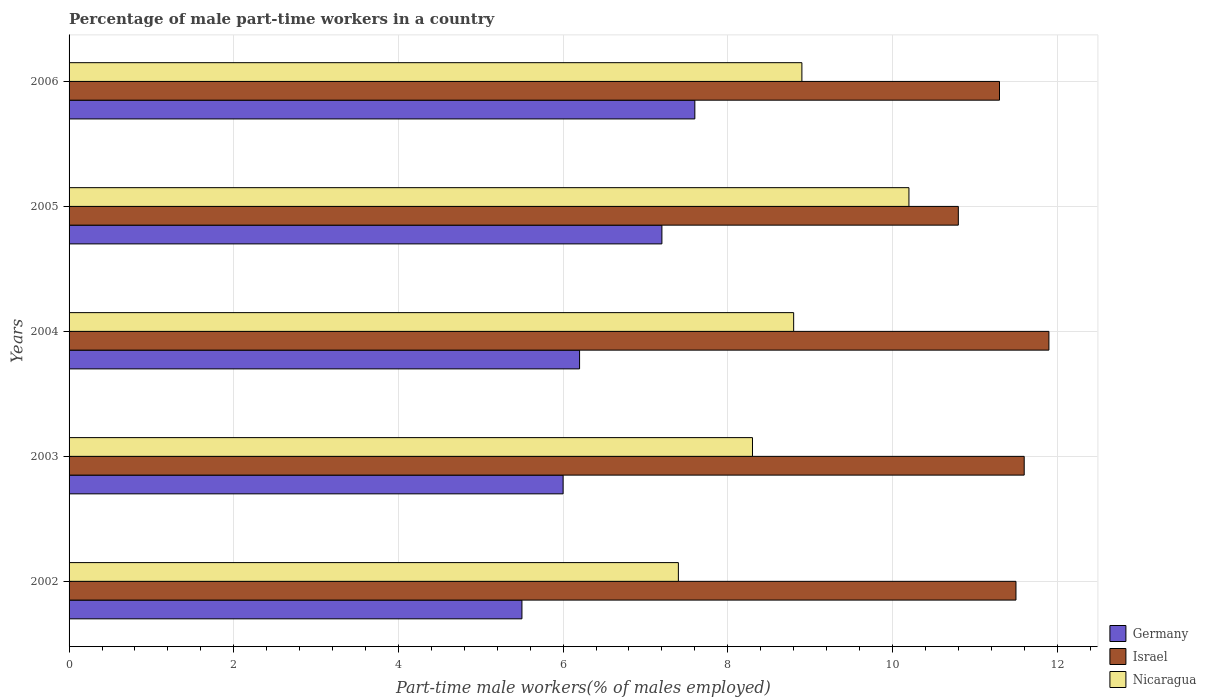Are the number of bars on each tick of the Y-axis equal?
Offer a terse response. Yes. How many bars are there on the 5th tick from the top?
Your answer should be very brief. 3. How many bars are there on the 1st tick from the bottom?
Offer a very short reply. 3. What is the label of the 3rd group of bars from the top?
Your answer should be very brief. 2004. In how many cases, is the number of bars for a given year not equal to the number of legend labels?
Ensure brevity in your answer.  0. What is the percentage of male part-time workers in Israel in 2006?
Give a very brief answer. 11.3. Across all years, what is the maximum percentage of male part-time workers in Nicaragua?
Ensure brevity in your answer.  10.2. Across all years, what is the minimum percentage of male part-time workers in Israel?
Your answer should be very brief. 10.8. What is the total percentage of male part-time workers in Nicaragua in the graph?
Your answer should be very brief. 43.6. What is the difference between the percentage of male part-time workers in Germany in 2002 and that in 2003?
Offer a terse response. -0.5. What is the difference between the percentage of male part-time workers in Israel in 2004 and the percentage of male part-time workers in Nicaragua in 2003?
Provide a short and direct response. 3.6. What is the average percentage of male part-time workers in Nicaragua per year?
Your answer should be compact. 8.72. In the year 2003, what is the difference between the percentage of male part-time workers in Israel and percentage of male part-time workers in Nicaragua?
Give a very brief answer. 3.3. What is the ratio of the percentage of male part-time workers in Israel in 2003 to that in 2004?
Keep it short and to the point. 0.97. Is the difference between the percentage of male part-time workers in Israel in 2004 and 2006 greater than the difference between the percentage of male part-time workers in Nicaragua in 2004 and 2006?
Give a very brief answer. Yes. What is the difference between the highest and the second highest percentage of male part-time workers in Nicaragua?
Provide a succinct answer. 1.3. What is the difference between the highest and the lowest percentage of male part-time workers in Nicaragua?
Provide a short and direct response. 2.8. In how many years, is the percentage of male part-time workers in Nicaragua greater than the average percentage of male part-time workers in Nicaragua taken over all years?
Ensure brevity in your answer.  3. What does the 1st bar from the top in 2002 represents?
Make the answer very short. Nicaragua. What is the difference between two consecutive major ticks on the X-axis?
Your answer should be compact. 2. Are the values on the major ticks of X-axis written in scientific E-notation?
Give a very brief answer. No. Does the graph contain any zero values?
Offer a terse response. No. How are the legend labels stacked?
Your answer should be very brief. Vertical. What is the title of the graph?
Keep it short and to the point. Percentage of male part-time workers in a country. Does "Lithuania" appear as one of the legend labels in the graph?
Your answer should be compact. No. What is the label or title of the X-axis?
Ensure brevity in your answer.  Part-time male workers(% of males employed). What is the label or title of the Y-axis?
Ensure brevity in your answer.  Years. What is the Part-time male workers(% of males employed) in Germany in 2002?
Your response must be concise. 5.5. What is the Part-time male workers(% of males employed) of Nicaragua in 2002?
Your response must be concise. 7.4. What is the Part-time male workers(% of males employed) of Germany in 2003?
Your answer should be compact. 6. What is the Part-time male workers(% of males employed) in Israel in 2003?
Give a very brief answer. 11.6. What is the Part-time male workers(% of males employed) in Nicaragua in 2003?
Offer a very short reply. 8.3. What is the Part-time male workers(% of males employed) of Germany in 2004?
Offer a terse response. 6.2. What is the Part-time male workers(% of males employed) in Israel in 2004?
Offer a terse response. 11.9. What is the Part-time male workers(% of males employed) in Nicaragua in 2004?
Make the answer very short. 8.8. What is the Part-time male workers(% of males employed) of Germany in 2005?
Provide a succinct answer. 7.2. What is the Part-time male workers(% of males employed) in Israel in 2005?
Your answer should be very brief. 10.8. What is the Part-time male workers(% of males employed) of Nicaragua in 2005?
Your answer should be compact. 10.2. What is the Part-time male workers(% of males employed) of Germany in 2006?
Make the answer very short. 7.6. What is the Part-time male workers(% of males employed) of Israel in 2006?
Keep it short and to the point. 11.3. What is the Part-time male workers(% of males employed) in Nicaragua in 2006?
Provide a short and direct response. 8.9. Across all years, what is the maximum Part-time male workers(% of males employed) of Germany?
Your answer should be compact. 7.6. Across all years, what is the maximum Part-time male workers(% of males employed) of Israel?
Give a very brief answer. 11.9. Across all years, what is the maximum Part-time male workers(% of males employed) in Nicaragua?
Your answer should be compact. 10.2. Across all years, what is the minimum Part-time male workers(% of males employed) of Israel?
Your response must be concise. 10.8. Across all years, what is the minimum Part-time male workers(% of males employed) in Nicaragua?
Make the answer very short. 7.4. What is the total Part-time male workers(% of males employed) of Germany in the graph?
Give a very brief answer. 32.5. What is the total Part-time male workers(% of males employed) of Israel in the graph?
Keep it short and to the point. 57.1. What is the total Part-time male workers(% of males employed) in Nicaragua in the graph?
Make the answer very short. 43.6. What is the difference between the Part-time male workers(% of males employed) of Germany in 2002 and that in 2004?
Give a very brief answer. -0.7. What is the difference between the Part-time male workers(% of males employed) of Israel in 2002 and that in 2004?
Provide a succinct answer. -0.4. What is the difference between the Part-time male workers(% of males employed) in Nicaragua in 2002 and that in 2004?
Offer a terse response. -1.4. What is the difference between the Part-time male workers(% of males employed) in Germany in 2002 and that in 2005?
Offer a very short reply. -1.7. What is the difference between the Part-time male workers(% of males employed) of Israel in 2002 and that in 2005?
Make the answer very short. 0.7. What is the difference between the Part-time male workers(% of males employed) of Germany in 2002 and that in 2006?
Make the answer very short. -2.1. What is the difference between the Part-time male workers(% of males employed) in Germany in 2003 and that in 2004?
Your response must be concise. -0.2. What is the difference between the Part-time male workers(% of males employed) of Israel in 2003 and that in 2004?
Offer a very short reply. -0.3. What is the difference between the Part-time male workers(% of males employed) of Germany in 2003 and that in 2005?
Offer a very short reply. -1.2. What is the difference between the Part-time male workers(% of males employed) in Israel in 2003 and that in 2005?
Give a very brief answer. 0.8. What is the difference between the Part-time male workers(% of males employed) of Nicaragua in 2003 and that in 2005?
Ensure brevity in your answer.  -1.9. What is the difference between the Part-time male workers(% of males employed) in Germany in 2003 and that in 2006?
Provide a succinct answer. -1.6. What is the difference between the Part-time male workers(% of males employed) of Nicaragua in 2003 and that in 2006?
Keep it short and to the point. -0.6. What is the difference between the Part-time male workers(% of males employed) of Israel in 2004 and that in 2005?
Provide a short and direct response. 1.1. What is the difference between the Part-time male workers(% of males employed) of Nicaragua in 2004 and that in 2005?
Offer a terse response. -1.4. What is the difference between the Part-time male workers(% of males employed) of Israel in 2004 and that in 2006?
Provide a short and direct response. 0.6. What is the difference between the Part-time male workers(% of males employed) of Israel in 2005 and that in 2006?
Offer a very short reply. -0.5. What is the difference between the Part-time male workers(% of males employed) of Germany in 2002 and the Part-time male workers(% of males employed) of Israel in 2003?
Offer a terse response. -6.1. What is the difference between the Part-time male workers(% of males employed) in Germany in 2002 and the Part-time male workers(% of males employed) in Nicaragua in 2003?
Make the answer very short. -2.8. What is the difference between the Part-time male workers(% of males employed) in Israel in 2002 and the Part-time male workers(% of males employed) in Nicaragua in 2003?
Keep it short and to the point. 3.2. What is the difference between the Part-time male workers(% of males employed) of Germany in 2002 and the Part-time male workers(% of males employed) of Israel in 2004?
Give a very brief answer. -6.4. What is the difference between the Part-time male workers(% of males employed) in Germany in 2002 and the Part-time male workers(% of males employed) in Nicaragua in 2004?
Make the answer very short. -3.3. What is the difference between the Part-time male workers(% of males employed) in Germany in 2002 and the Part-time male workers(% of males employed) in Israel in 2005?
Keep it short and to the point. -5.3. What is the difference between the Part-time male workers(% of males employed) in Israel in 2002 and the Part-time male workers(% of males employed) in Nicaragua in 2005?
Offer a very short reply. 1.3. What is the difference between the Part-time male workers(% of males employed) of Israel in 2003 and the Part-time male workers(% of males employed) of Nicaragua in 2004?
Provide a short and direct response. 2.8. What is the difference between the Part-time male workers(% of males employed) in Germany in 2003 and the Part-time male workers(% of males employed) in Israel in 2005?
Your answer should be compact. -4.8. What is the difference between the Part-time male workers(% of males employed) of Germany in 2003 and the Part-time male workers(% of males employed) of Nicaragua in 2006?
Offer a terse response. -2.9. What is the difference between the Part-time male workers(% of males employed) in Germany in 2004 and the Part-time male workers(% of males employed) in Israel in 2005?
Give a very brief answer. -4.6. What is the difference between the Part-time male workers(% of males employed) of Germany in 2004 and the Part-time male workers(% of males employed) of Nicaragua in 2005?
Make the answer very short. -4. What is the difference between the Part-time male workers(% of males employed) in Israel in 2004 and the Part-time male workers(% of males employed) in Nicaragua in 2005?
Keep it short and to the point. 1.7. What is the difference between the Part-time male workers(% of males employed) in Germany in 2004 and the Part-time male workers(% of males employed) in Israel in 2006?
Ensure brevity in your answer.  -5.1. What is the difference between the Part-time male workers(% of males employed) of Germany in 2005 and the Part-time male workers(% of males employed) of Nicaragua in 2006?
Make the answer very short. -1.7. What is the difference between the Part-time male workers(% of males employed) of Israel in 2005 and the Part-time male workers(% of males employed) of Nicaragua in 2006?
Provide a short and direct response. 1.9. What is the average Part-time male workers(% of males employed) of Israel per year?
Offer a terse response. 11.42. What is the average Part-time male workers(% of males employed) in Nicaragua per year?
Your response must be concise. 8.72. In the year 2002, what is the difference between the Part-time male workers(% of males employed) of Germany and Part-time male workers(% of males employed) of Nicaragua?
Give a very brief answer. -1.9. In the year 2003, what is the difference between the Part-time male workers(% of males employed) in Germany and Part-time male workers(% of males employed) in Israel?
Your answer should be very brief. -5.6. In the year 2004, what is the difference between the Part-time male workers(% of males employed) of Germany and Part-time male workers(% of males employed) of Nicaragua?
Your response must be concise. -2.6. In the year 2004, what is the difference between the Part-time male workers(% of males employed) in Israel and Part-time male workers(% of males employed) in Nicaragua?
Give a very brief answer. 3.1. In the year 2005, what is the difference between the Part-time male workers(% of males employed) of Germany and Part-time male workers(% of males employed) of Israel?
Offer a terse response. -3.6. In the year 2005, what is the difference between the Part-time male workers(% of males employed) in Israel and Part-time male workers(% of males employed) in Nicaragua?
Offer a terse response. 0.6. In the year 2006, what is the difference between the Part-time male workers(% of males employed) in Germany and Part-time male workers(% of males employed) in Israel?
Provide a short and direct response. -3.7. In the year 2006, what is the difference between the Part-time male workers(% of males employed) in Germany and Part-time male workers(% of males employed) in Nicaragua?
Make the answer very short. -1.3. What is the ratio of the Part-time male workers(% of males employed) of Germany in 2002 to that in 2003?
Your response must be concise. 0.92. What is the ratio of the Part-time male workers(% of males employed) in Nicaragua in 2002 to that in 2003?
Provide a short and direct response. 0.89. What is the ratio of the Part-time male workers(% of males employed) in Germany in 2002 to that in 2004?
Keep it short and to the point. 0.89. What is the ratio of the Part-time male workers(% of males employed) of Israel in 2002 to that in 2004?
Offer a very short reply. 0.97. What is the ratio of the Part-time male workers(% of males employed) in Nicaragua in 2002 to that in 2004?
Keep it short and to the point. 0.84. What is the ratio of the Part-time male workers(% of males employed) of Germany in 2002 to that in 2005?
Give a very brief answer. 0.76. What is the ratio of the Part-time male workers(% of males employed) of Israel in 2002 to that in 2005?
Your answer should be very brief. 1.06. What is the ratio of the Part-time male workers(% of males employed) in Nicaragua in 2002 to that in 2005?
Your answer should be very brief. 0.73. What is the ratio of the Part-time male workers(% of males employed) of Germany in 2002 to that in 2006?
Keep it short and to the point. 0.72. What is the ratio of the Part-time male workers(% of males employed) of Israel in 2002 to that in 2006?
Your response must be concise. 1.02. What is the ratio of the Part-time male workers(% of males employed) in Nicaragua in 2002 to that in 2006?
Offer a terse response. 0.83. What is the ratio of the Part-time male workers(% of males employed) of Israel in 2003 to that in 2004?
Your response must be concise. 0.97. What is the ratio of the Part-time male workers(% of males employed) of Nicaragua in 2003 to that in 2004?
Offer a very short reply. 0.94. What is the ratio of the Part-time male workers(% of males employed) of Israel in 2003 to that in 2005?
Provide a short and direct response. 1.07. What is the ratio of the Part-time male workers(% of males employed) of Nicaragua in 2003 to that in 2005?
Provide a short and direct response. 0.81. What is the ratio of the Part-time male workers(% of males employed) in Germany in 2003 to that in 2006?
Provide a succinct answer. 0.79. What is the ratio of the Part-time male workers(% of males employed) in Israel in 2003 to that in 2006?
Provide a short and direct response. 1.03. What is the ratio of the Part-time male workers(% of males employed) in Nicaragua in 2003 to that in 2006?
Keep it short and to the point. 0.93. What is the ratio of the Part-time male workers(% of males employed) in Germany in 2004 to that in 2005?
Provide a succinct answer. 0.86. What is the ratio of the Part-time male workers(% of males employed) of Israel in 2004 to that in 2005?
Keep it short and to the point. 1.1. What is the ratio of the Part-time male workers(% of males employed) of Nicaragua in 2004 to that in 2005?
Make the answer very short. 0.86. What is the ratio of the Part-time male workers(% of males employed) in Germany in 2004 to that in 2006?
Make the answer very short. 0.82. What is the ratio of the Part-time male workers(% of males employed) in Israel in 2004 to that in 2006?
Ensure brevity in your answer.  1.05. What is the ratio of the Part-time male workers(% of males employed) in Israel in 2005 to that in 2006?
Make the answer very short. 0.96. What is the ratio of the Part-time male workers(% of males employed) in Nicaragua in 2005 to that in 2006?
Provide a succinct answer. 1.15. What is the difference between the highest and the second highest Part-time male workers(% of males employed) of Israel?
Provide a short and direct response. 0.3. What is the difference between the highest and the lowest Part-time male workers(% of males employed) of Israel?
Ensure brevity in your answer.  1.1. What is the difference between the highest and the lowest Part-time male workers(% of males employed) in Nicaragua?
Make the answer very short. 2.8. 